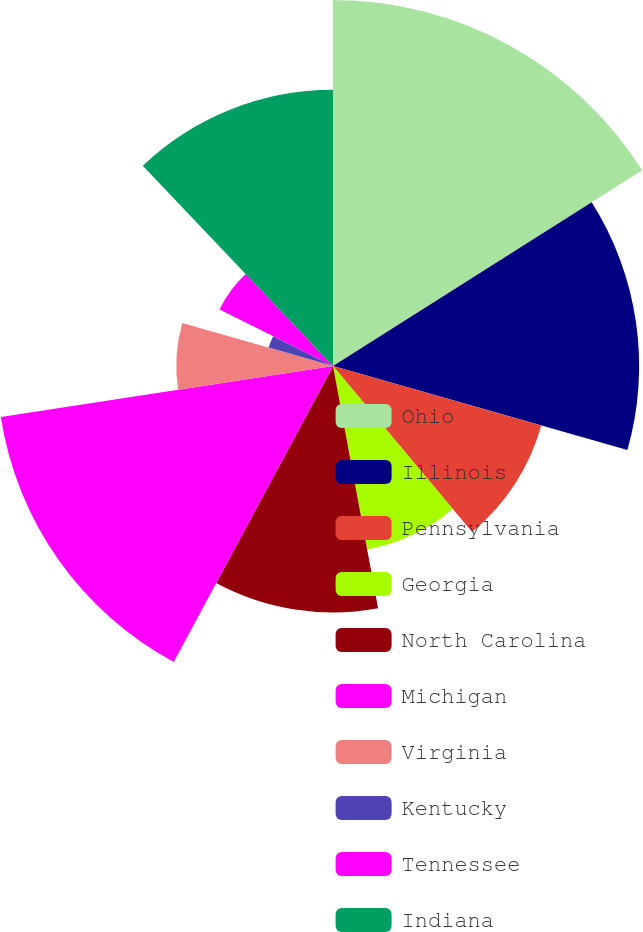Convert chart to OTSL. <chart><loc_0><loc_0><loc_500><loc_500><pie_chart><fcel>Ohio<fcel>Illinois<fcel>Pennsylvania<fcel>Georgia<fcel>North Carolina<fcel>Michigan<fcel>Virginia<fcel>Kentucky<fcel>Tennessee<fcel>Indiana<nl><fcel>16.02%<fcel>13.4%<fcel>9.48%<fcel>8.17%<fcel>10.79%<fcel>14.71%<fcel>6.86%<fcel>2.93%<fcel>5.55%<fcel>12.09%<nl></chart> 